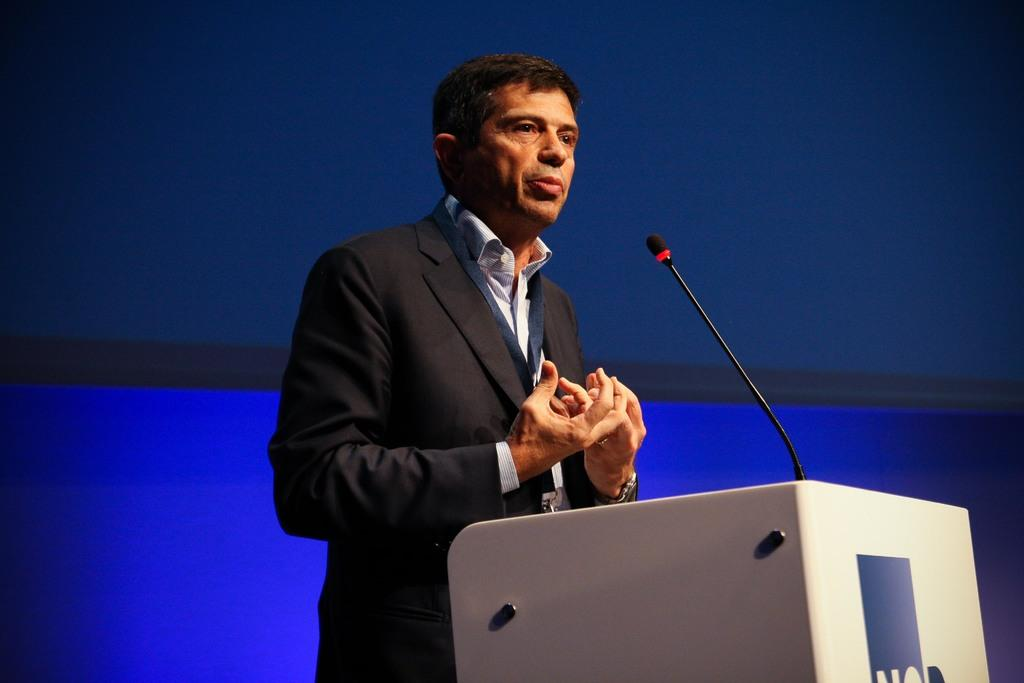What is the man in the image doing? The man is standing at a podium in the image. What is on the podium with the man? There is a microphone on the podium. What can be seen behind the man in the image? There are objects visible in the background of the image. How many tickets does the man have in his hand in the image? There is no indication in the image that the man has any tickets in his hand. 